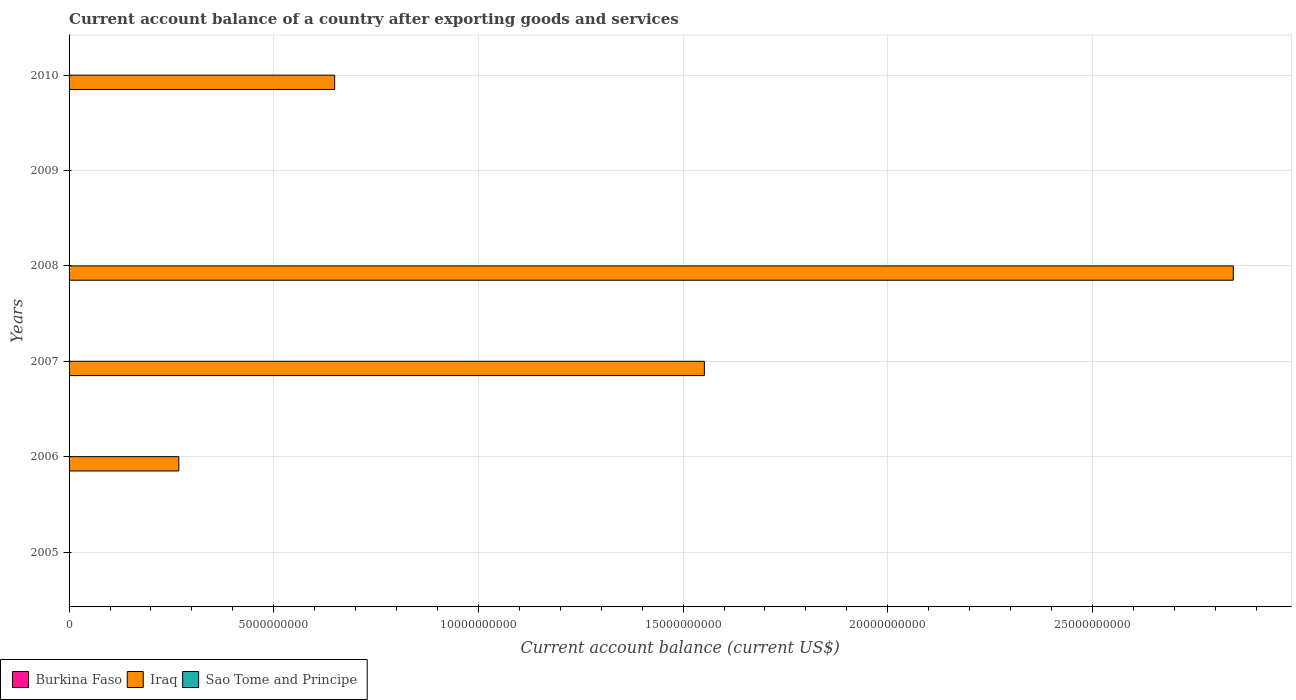Are the number of bars per tick equal to the number of legend labels?
Ensure brevity in your answer.  No. Are the number of bars on each tick of the Y-axis equal?
Offer a very short reply. No. How many bars are there on the 5th tick from the top?
Provide a short and direct response. 1. What is the account balance in Sao Tome and Principe in 2009?
Provide a short and direct response. 0. Across all years, what is the maximum account balance in Iraq?
Keep it short and to the point. 2.84e+1. In which year was the account balance in Iraq maximum?
Your answer should be compact. 2008. What is the difference between the account balance in Iraq in 2006 and the account balance in Burkina Faso in 2007?
Offer a terse response. 2.68e+09. What is the average account balance in Sao Tome and Principe per year?
Your answer should be compact. 0. In how many years, is the account balance in Burkina Faso greater than 6000000000 US$?
Provide a short and direct response. 0. What is the difference between the highest and the second highest account balance in Iraq?
Your answer should be very brief. 1.29e+1. What is the difference between the highest and the lowest account balance in Iraq?
Your answer should be very brief. 2.84e+1. Is it the case that in every year, the sum of the account balance in Iraq and account balance in Sao Tome and Principe is greater than the account balance in Burkina Faso?
Offer a very short reply. No. Does the graph contain any zero values?
Offer a terse response. Yes. Does the graph contain grids?
Give a very brief answer. Yes. How are the legend labels stacked?
Provide a succinct answer. Horizontal. What is the title of the graph?
Your answer should be compact. Current account balance of a country after exporting goods and services. Does "Puerto Rico" appear as one of the legend labels in the graph?
Keep it short and to the point. No. What is the label or title of the X-axis?
Your answer should be compact. Current account balance (current US$). What is the label or title of the Y-axis?
Your answer should be very brief. Years. What is the Current account balance (current US$) of Burkina Faso in 2005?
Provide a succinct answer. 0. What is the Current account balance (current US$) of Iraq in 2006?
Make the answer very short. 2.68e+09. What is the Current account balance (current US$) in Iraq in 2007?
Ensure brevity in your answer.  1.55e+1. What is the Current account balance (current US$) in Iraq in 2008?
Provide a short and direct response. 2.84e+1. What is the Current account balance (current US$) of Sao Tome and Principe in 2008?
Offer a very short reply. 0. What is the Current account balance (current US$) of Iraq in 2009?
Ensure brevity in your answer.  0. What is the Current account balance (current US$) of Sao Tome and Principe in 2009?
Make the answer very short. 0. What is the Current account balance (current US$) in Burkina Faso in 2010?
Offer a terse response. 0. What is the Current account balance (current US$) of Iraq in 2010?
Keep it short and to the point. 6.49e+09. What is the Current account balance (current US$) of Sao Tome and Principe in 2010?
Provide a short and direct response. 0. Across all years, what is the maximum Current account balance (current US$) in Iraq?
Keep it short and to the point. 2.84e+1. Across all years, what is the minimum Current account balance (current US$) in Iraq?
Make the answer very short. 0. What is the total Current account balance (current US$) of Iraq in the graph?
Offer a terse response. 5.31e+1. What is the total Current account balance (current US$) in Sao Tome and Principe in the graph?
Keep it short and to the point. 0. What is the difference between the Current account balance (current US$) in Iraq in 2006 and that in 2007?
Make the answer very short. -1.28e+1. What is the difference between the Current account balance (current US$) in Iraq in 2006 and that in 2008?
Offer a very short reply. -2.58e+1. What is the difference between the Current account balance (current US$) in Iraq in 2006 and that in 2010?
Provide a succinct answer. -3.81e+09. What is the difference between the Current account balance (current US$) of Iraq in 2007 and that in 2008?
Your answer should be compact. -1.29e+1. What is the difference between the Current account balance (current US$) in Iraq in 2007 and that in 2010?
Your answer should be compact. 9.03e+09. What is the difference between the Current account balance (current US$) of Iraq in 2008 and that in 2010?
Your answer should be compact. 2.20e+1. What is the average Current account balance (current US$) in Iraq per year?
Your answer should be compact. 8.85e+09. What is the average Current account balance (current US$) in Sao Tome and Principe per year?
Give a very brief answer. 0. What is the ratio of the Current account balance (current US$) of Iraq in 2006 to that in 2007?
Provide a short and direct response. 0.17. What is the ratio of the Current account balance (current US$) of Iraq in 2006 to that in 2008?
Your answer should be compact. 0.09. What is the ratio of the Current account balance (current US$) in Iraq in 2006 to that in 2010?
Your answer should be compact. 0.41. What is the ratio of the Current account balance (current US$) of Iraq in 2007 to that in 2008?
Your response must be concise. 0.55. What is the ratio of the Current account balance (current US$) in Iraq in 2007 to that in 2010?
Your response must be concise. 2.39. What is the ratio of the Current account balance (current US$) of Iraq in 2008 to that in 2010?
Provide a short and direct response. 4.38. What is the difference between the highest and the second highest Current account balance (current US$) of Iraq?
Keep it short and to the point. 1.29e+1. What is the difference between the highest and the lowest Current account balance (current US$) in Iraq?
Give a very brief answer. 2.84e+1. 